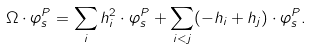Convert formula to latex. <formula><loc_0><loc_0><loc_500><loc_500>\Omega \cdot \varphi ^ { P } _ { s } = \sum _ { i } h _ { i } ^ { 2 } \cdot \varphi ^ { P } _ { s } + \sum _ { i < j } ( - h _ { i } + h _ { j } ) \cdot \varphi ^ { P } _ { s } .</formula> 